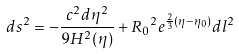<formula> <loc_0><loc_0><loc_500><loc_500>d s ^ { 2 } = - \frac { c ^ { 2 } d \eta ^ { 2 } } { 9 H ^ { 2 } ( \eta ) } + { R _ { 0 } } ^ { 2 } e ^ { \frac { 2 } { 3 } ( \eta - \eta _ { 0 } ) } d l ^ { 2 }</formula> 